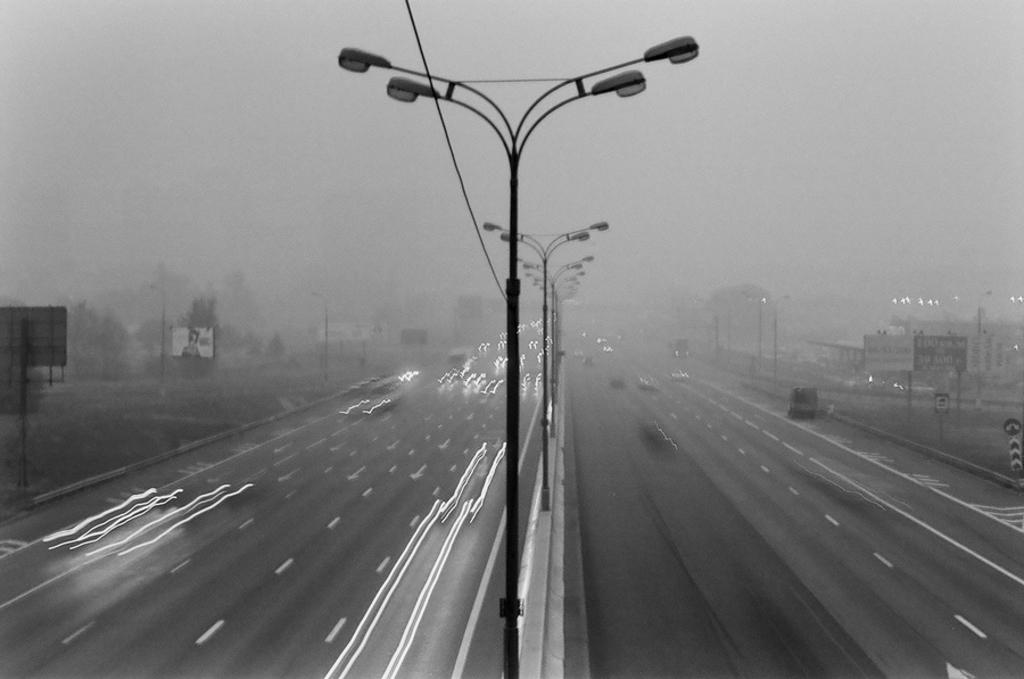What can be seen on the road in the image? There are vehicles on the road in the image. What type of infrastructure is present in the image? There are street lights, poles, buildings, and trees in the image. What is the primary surface visible in the image? There is a road visible at the bottom of the image. What type of collar can be seen on the flag in the image? There is no flag or collar present in the image. What idea does the image represent? The image does not represent a specific idea; it is a scene with vehicles, street lights, poles, buildings, trees, and a road. 